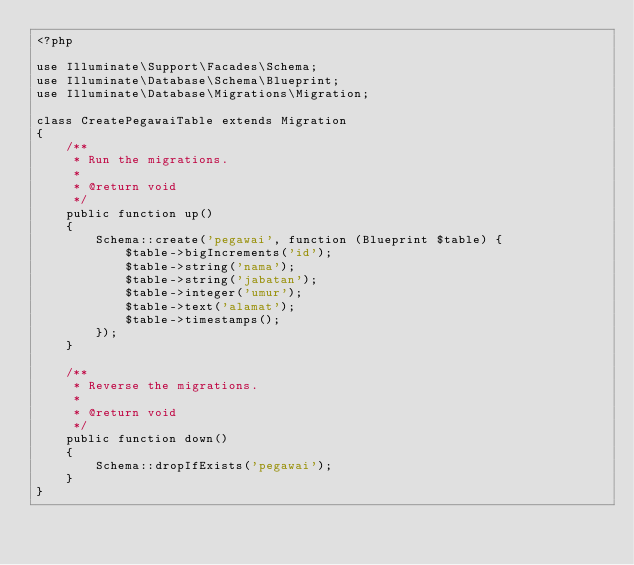<code> <loc_0><loc_0><loc_500><loc_500><_PHP_><?php

use Illuminate\Support\Facades\Schema;
use Illuminate\Database\Schema\Blueprint;
use Illuminate\Database\Migrations\Migration;

class CreatePegawaiTable extends Migration
{
    /**
     * Run the migrations.
     *
     * @return void
     */
    public function up()
    {
        Schema::create('pegawai', function (Blueprint $table) {
            $table->bigIncrements('id');
            $table->string('nama');
            $table->string('jabatan');
            $table->integer('umur');
            $table->text('alamat');
            $table->timestamps();
        });
    }

    /**
     * Reverse the migrations.
     *
     * @return void
     */
    public function down()
    {
        Schema::dropIfExists('pegawai');
    }
}
</code> 